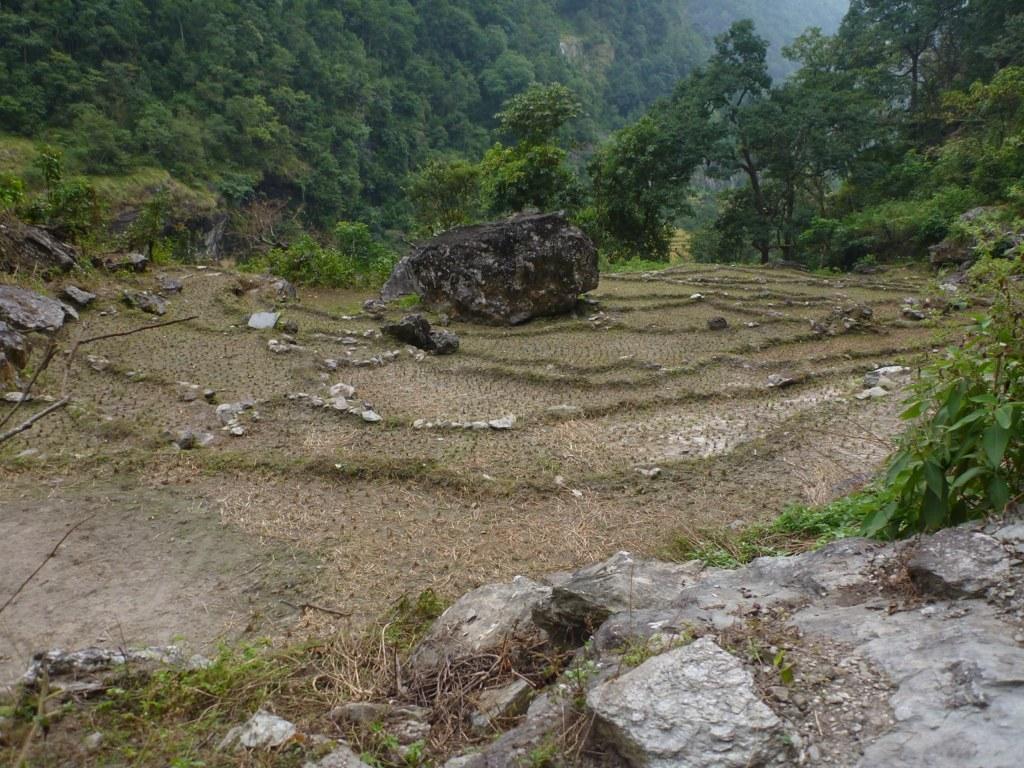Please provide a concise description of this image. In this image there is a field, in that field there are rocks, in the background there are trees. 